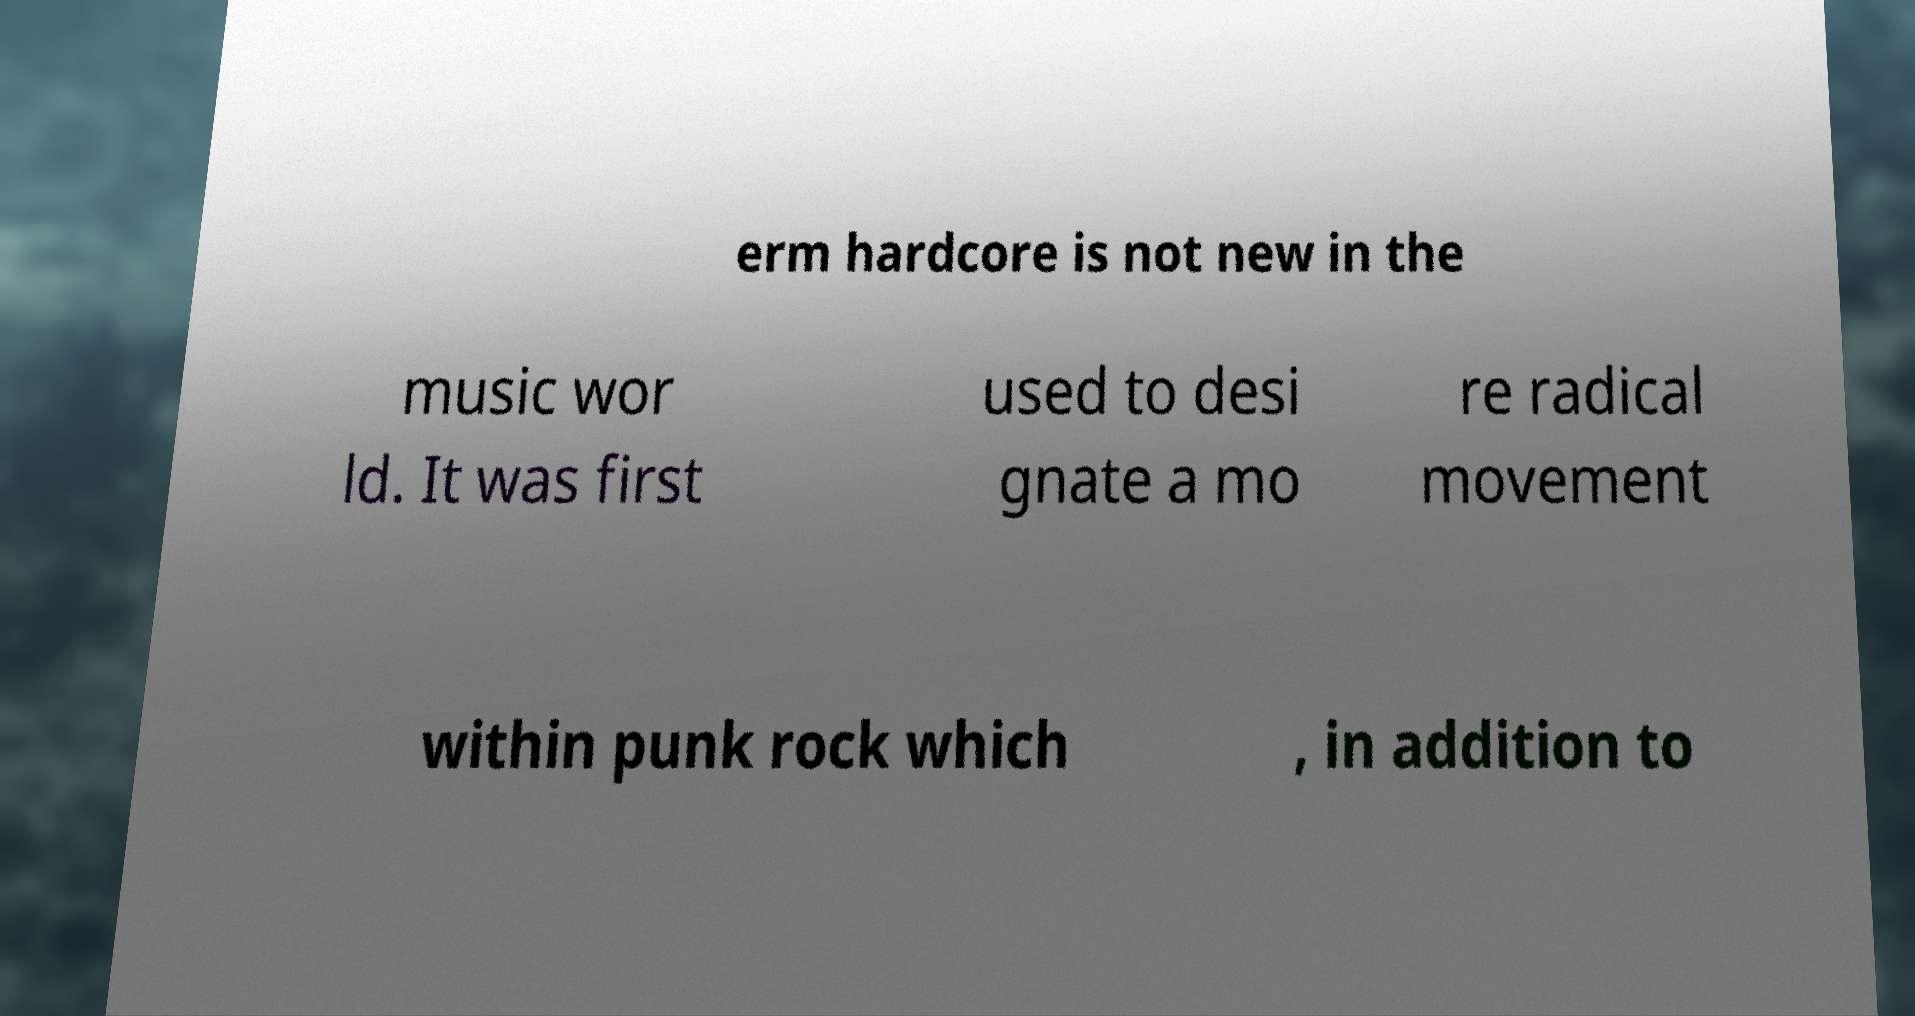Please identify and transcribe the text found in this image. erm hardcore is not new in the music wor ld. It was first used to desi gnate a mo re radical movement within punk rock which , in addition to 